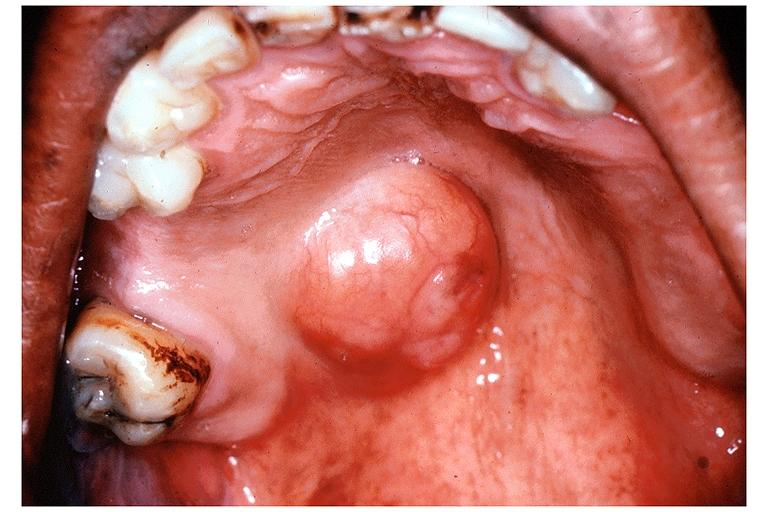s chest and abdomen slide present?
Answer the question using a single word or phrase. No 